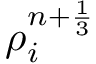Convert formula to latex. <formula><loc_0><loc_0><loc_500><loc_500>{ \rho } _ { i } ^ { n + \frac { 1 } { 3 } }</formula> 